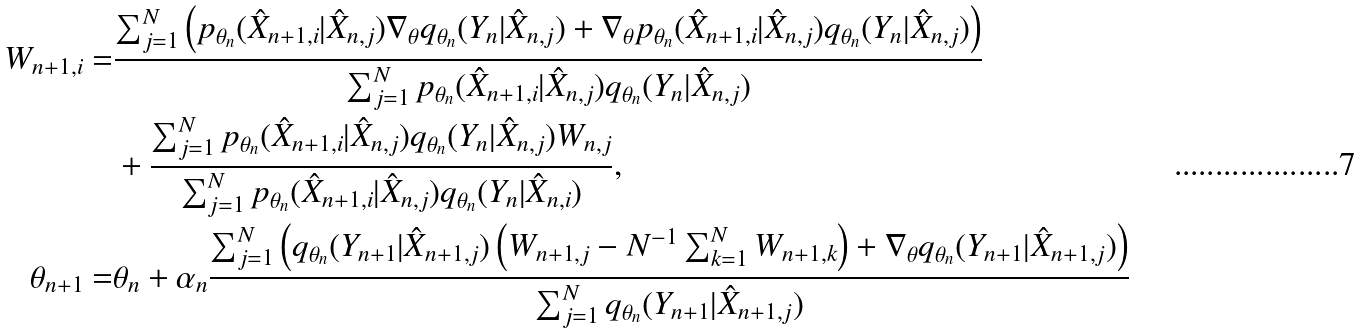Convert formula to latex. <formula><loc_0><loc_0><loc_500><loc_500>W _ { n + 1 , i } = & \frac { \sum _ { j = 1 } ^ { N } \left ( p _ { \theta _ { n } } ( \hat { X } _ { n + 1 , i } | \hat { X } _ { n , j } ) \nabla _ { \theta } q _ { \theta _ { n } } ( Y _ { n } | \hat { X } _ { n , j } ) + \nabla _ { \theta } p _ { \theta _ { n } } ( \hat { X } _ { n + 1 , i } | \hat { X } _ { n , j } ) q _ { \theta _ { n } } ( Y _ { n } | \hat { X } _ { n , j } ) \right ) } { \sum _ { j = 1 } ^ { N } p _ { \theta _ { n } } ( \hat { X } _ { n + 1 , i } | \hat { X } _ { n , j } ) q _ { \theta _ { n } } ( Y _ { n } | \hat { X } _ { n , j } ) } \\ & + \frac { \sum _ { j = 1 } ^ { N } p _ { \theta _ { n } } ( \hat { X } _ { n + 1 , i } | \hat { X } _ { n , j } ) q _ { \theta _ { n } } ( Y _ { n } | \hat { X } _ { n , j } ) W _ { n , j } } { \sum _ { j = 1 } ^ { N } p _ { \theta _ { n } } ( \hat { X } _ { n + 1 , i } | \hat { X } _ { n , j } ) q _ { \theta _ { n } } ( Y _ { n } | \hat { X } _ { n , i } ) } , \\ \theta _ { n + 1 } = & \theta _ { n } + \alpha _ { n } \frac { \sum _ { j = 1 } ^ { N } \left ( q _ { \theta _ { n } } ( Y _ { n + 1 } | \hat { X } _ { n + 1 , j } ) \left ( W _ { n + 1 , j } - N ^ { - 1 } \sum _ { k = 1 } ^ { N } W _ { n + 1 , k } \right ) + \nabla _ { \theta } q _ { \theta _ { n } } ( Y _ { n + 1 } | \hat { X } _ { n + 1 , j } ) \right ) } { \sum _ { j = 1 } ^ { N } q _ { \theta _ { n } } ( Y _ { n + 1 } | \hat { X } _ { n + 1 , j } ) }</formula> 